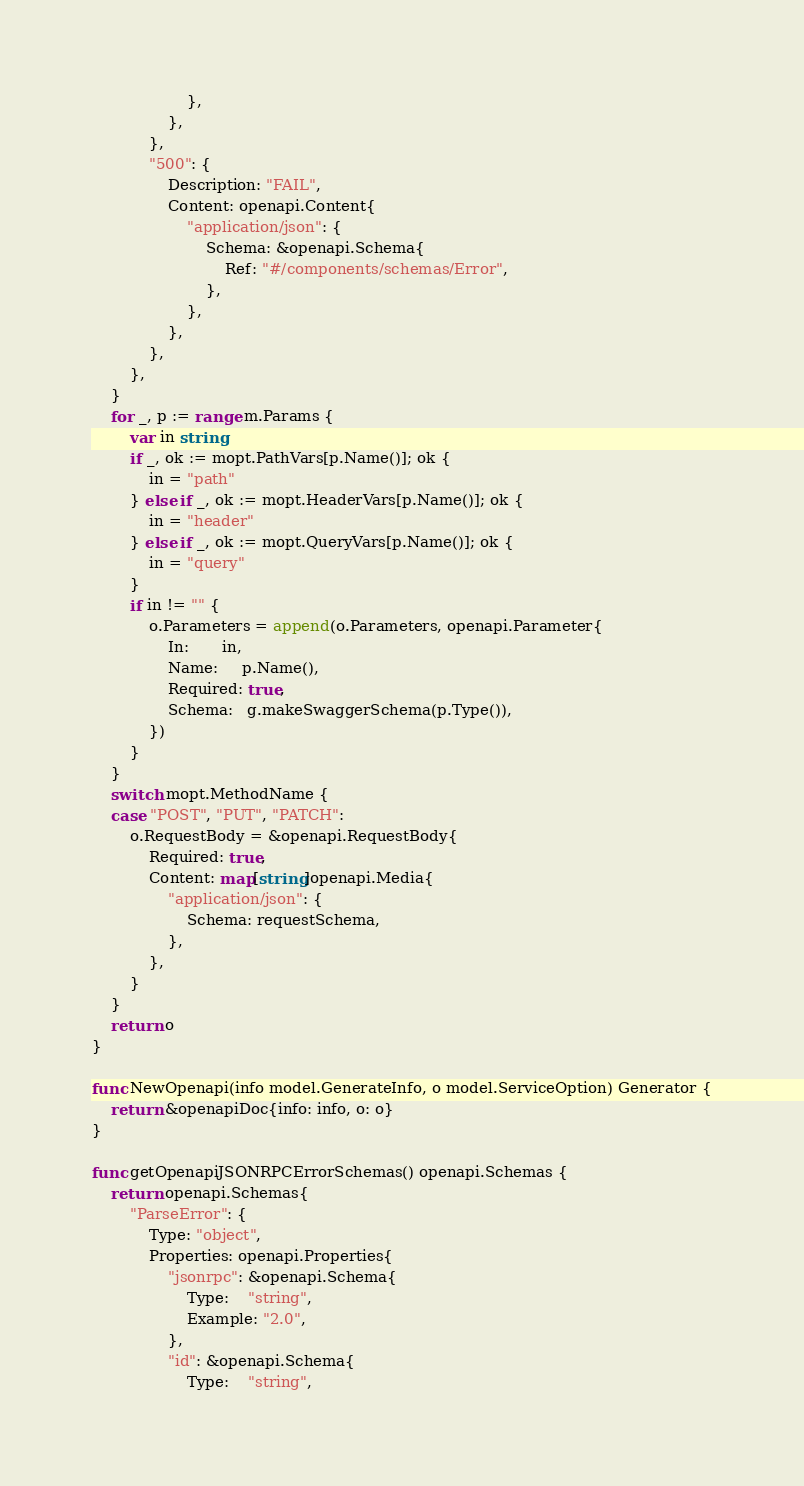<code> <loc_0><loc_0><loc_500><loc_500><_Go_>					},
				},
			},
			"500": {
				Description: "FAIL",
				Content: openapi.Content{
					"application/json": {
						Schema: &openapi.Schema{
							Ref: "#/components/schemas/Error",
						},
					},
				},
			},
		},
	}
	for _, p := range m.Params {
		var in string
		if _, ok := mopt.PathVars[p.Name()]; ok {
			in = "path"
		} else if _, ok := mopt.HeaderVars[p.Name()]; ok {
			in = "header"
		} else if _, ok := mopt.QueryVars[p.Name()]; ok {
			in = "query"
		}
		if in != "" {
			o.Parameters = append(o.Parameters, openapi.Parameter{
				In:       in,
				Name:     p.Name(),
				Required: true,
				Schema:   g.makeSwaggerSchema(p.Type()),
			})
		}
	}
	switch mopt.MethodName {
	case "POST", "PUT", "PATCH":
		o.RequestBody = &openapi.RequestBody{
			Required: true,
			Content: map[string]openapi.Media{
				"application/json": {
					Schema: requestSchema,
				},
			},
		}
	}
	return o
}

func NewOpenapi(info model.GenerateInfo, o model.ServiceOption) Generator {
	return &openapiDoc{info: info, o: o}
}

func getOpenapiJSONRPCErrorSchemas() openapi.Schemas {
	return openapi.Schemas{
		"ParseError": {
			Type: "object",
			Properties: openapi.Properties{
				"jsonrpc": &openapi.Schema{
					Type:    "string",
					Example: "2.0",
				},
				"id": &openapi.Schema{
					Type:    "string",</code> 